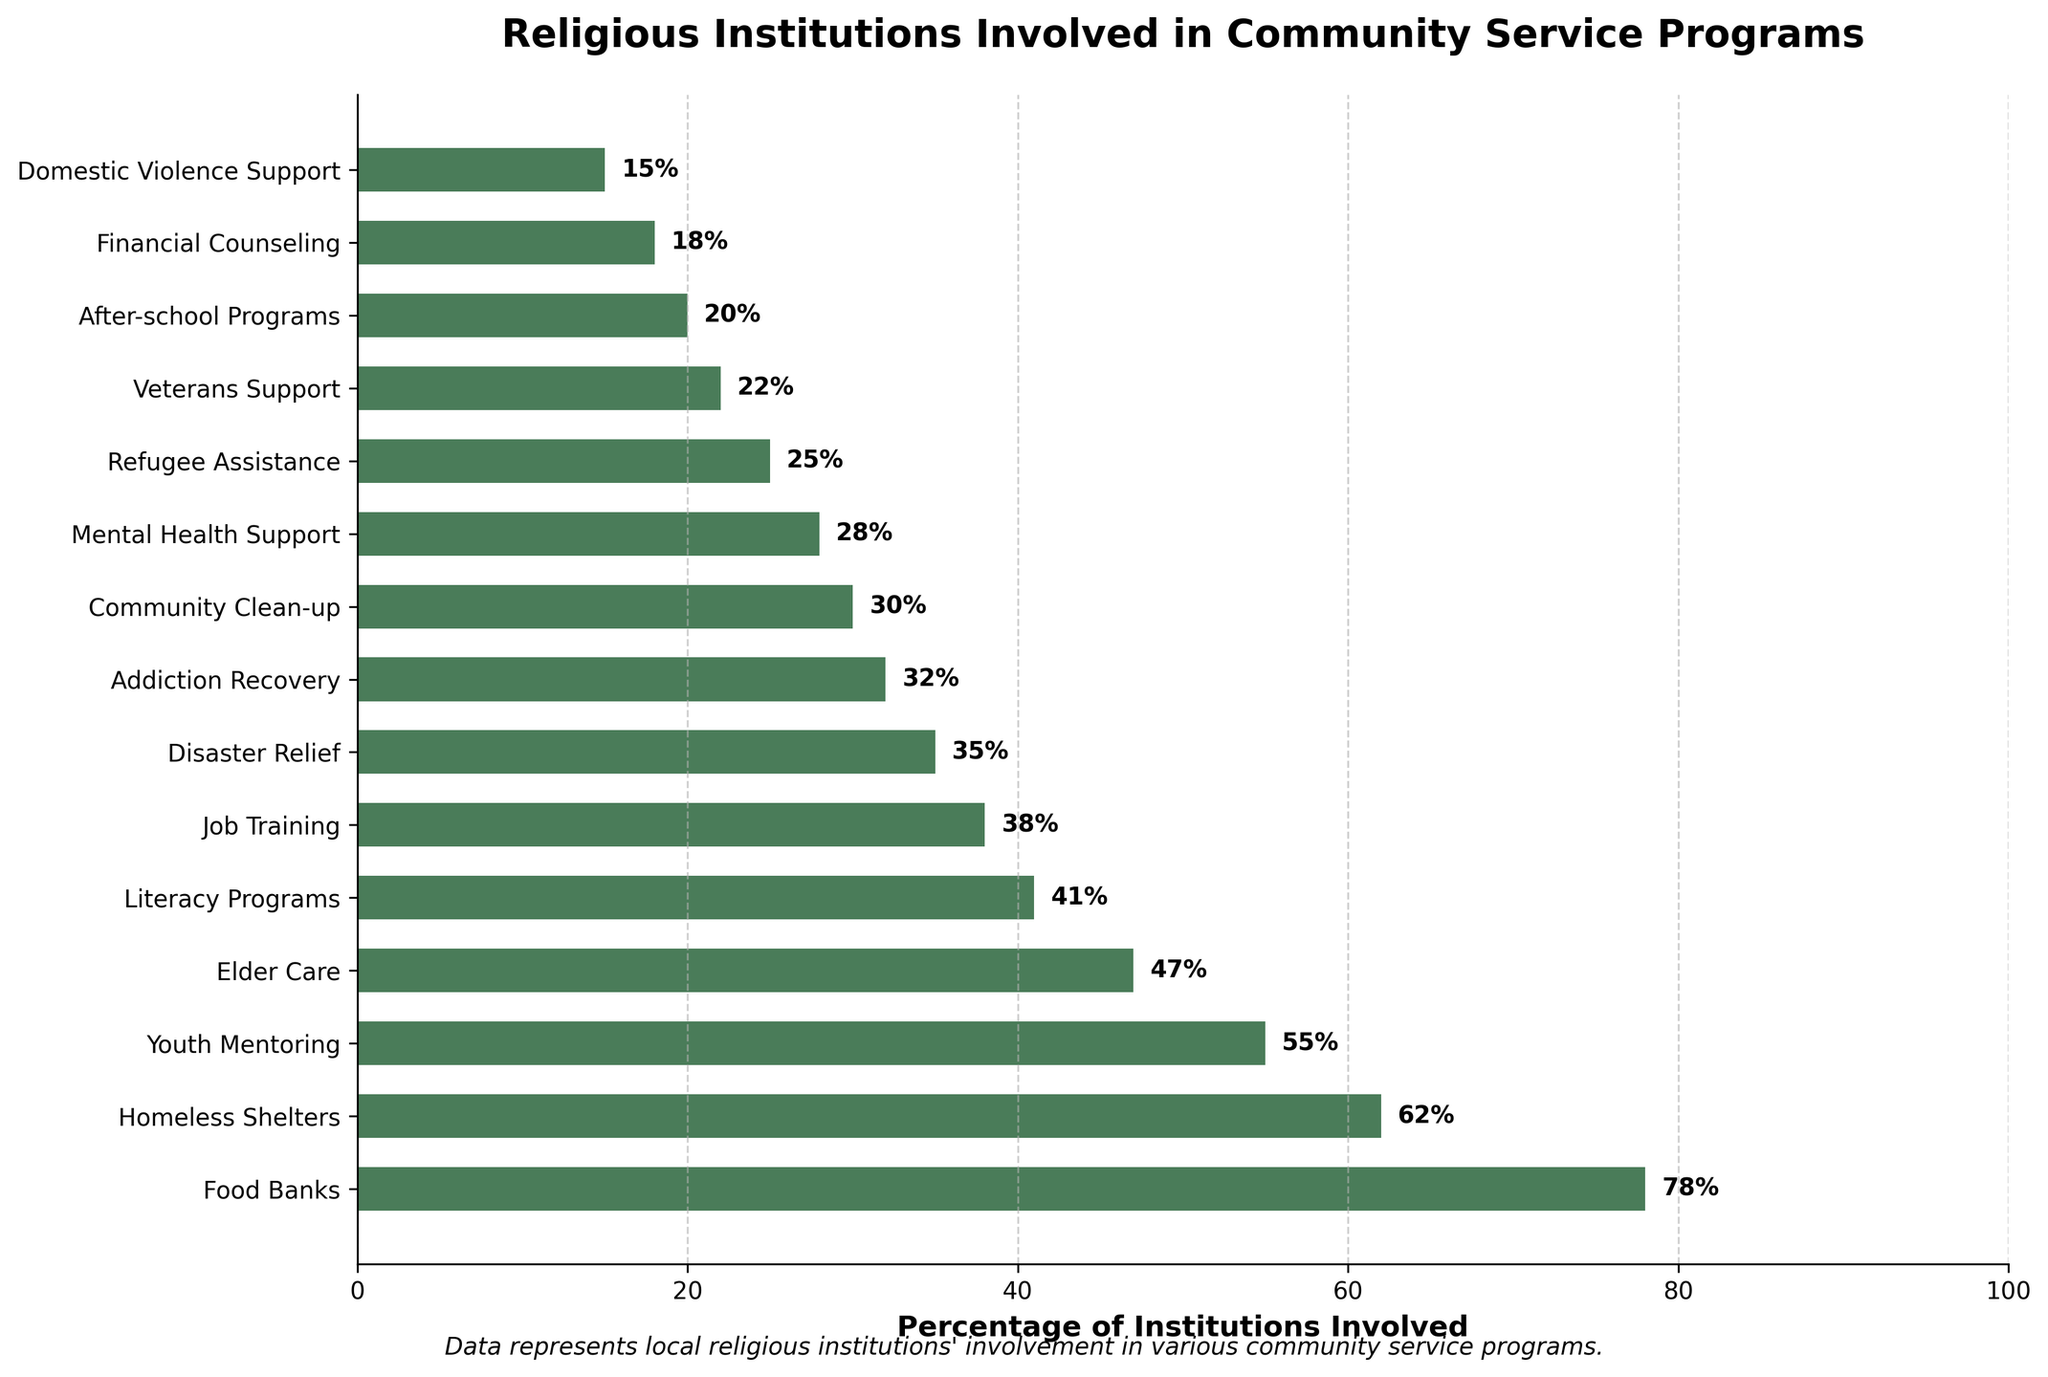Which type of service has the highest percentage of involvement from local religious institutions? The bar chart shows the percentage of local religious institutions involved in different community service programs. By visually checking the lengths of the bars, "Food Banks" has the longest bar at 78%.
Answer: Food Banks What is the difference in percentage involvement between Youth Mentoring and Financial Counseling programs? From the figure, the percentage of institutions involved in Youth Mentoring is 55% and the percentage in Financial Counseling is 18%. The difference is calculated as 55% - 18% = 37%.
Answer: 37% Among the top three services with the highest involvement, what is the average percentage of institutions involved? The top three services with the highest involvement are Food Banks (78%), Homeless Shelters (62%), and Youth Mentoring (55%). The average percentage is calculated as (78 + 62 + 55) / 3 = 195 / 3 = 65%.
Answer: 65% Which programs have less than 30% of institutions involved? By identifying the bars that do not extend beyond the 30% mark, the services are: Mental Health Support (28%), Refugee Assistance (25%), Veterans Support (22%), After-school Programs (20%), Financial Counseling (18%), and Domestic Violence Support (15%).
Answer: Mental Health Support, Refugee Assistance, Veterans Support, After-school Programs, Financial Counseling, Domestic Violence Support Is the involvement in Disaster Relief programs higher than that in Job Training programs? If so, by how much? The percentage of institutions involved in Disaster Relief is 35%, and in Job Training, it’s 38%. Since 35% is less than 38%, involvement in Disaster Relief is not higher.
Answer: No, 0% What is the median percentage of all involvement rates shown in the chart? First, list all involvement rates in ascending order: 15%, 18%, 20%, 22%, 25%, 28%, 30%, 32%, 35%, 38%, 41%, 47%, 55%, 62%, 78%. The median is the middle value of this ordered list, which is the 8th value, 32%.
Answer: 32% How much greater is the involvement in Elder Care compared to Literacy Programs? The percentage of institutions involved in Elder Care is 47%, while in Literacy Programs, it is 41%. The difference is 47% - 41% = 6%.
Answer: 6% What is the sum of the percentages for Food Banks, Community Clean-up, and Domestic Violence Support programs? Adding the percentages for these services: Food Banks (78%), Community Clean-up (30%), Domestic Violence Support (15%) results in 78 + 30 + 15 = 123%.
Answer: 123% Which program has the least percentage of institutions involved, and what is the percentage? The bar with the shortest length indicates "Domestic Violence Support" with a percentage of 15%.
Answer: Domestic Violence Support, 15% If we combine the involvement in Food Banks, Homeless Shelters, and Youth Mentoring, what is the combined total percentage? Add the percentages of institutions involved in the three programs: Food Banks (78%), Homeless Shelters (62%), and Youth Mentoring (55%). The total is 78 + 62 + 55 = 195%.
Answer: 195% 